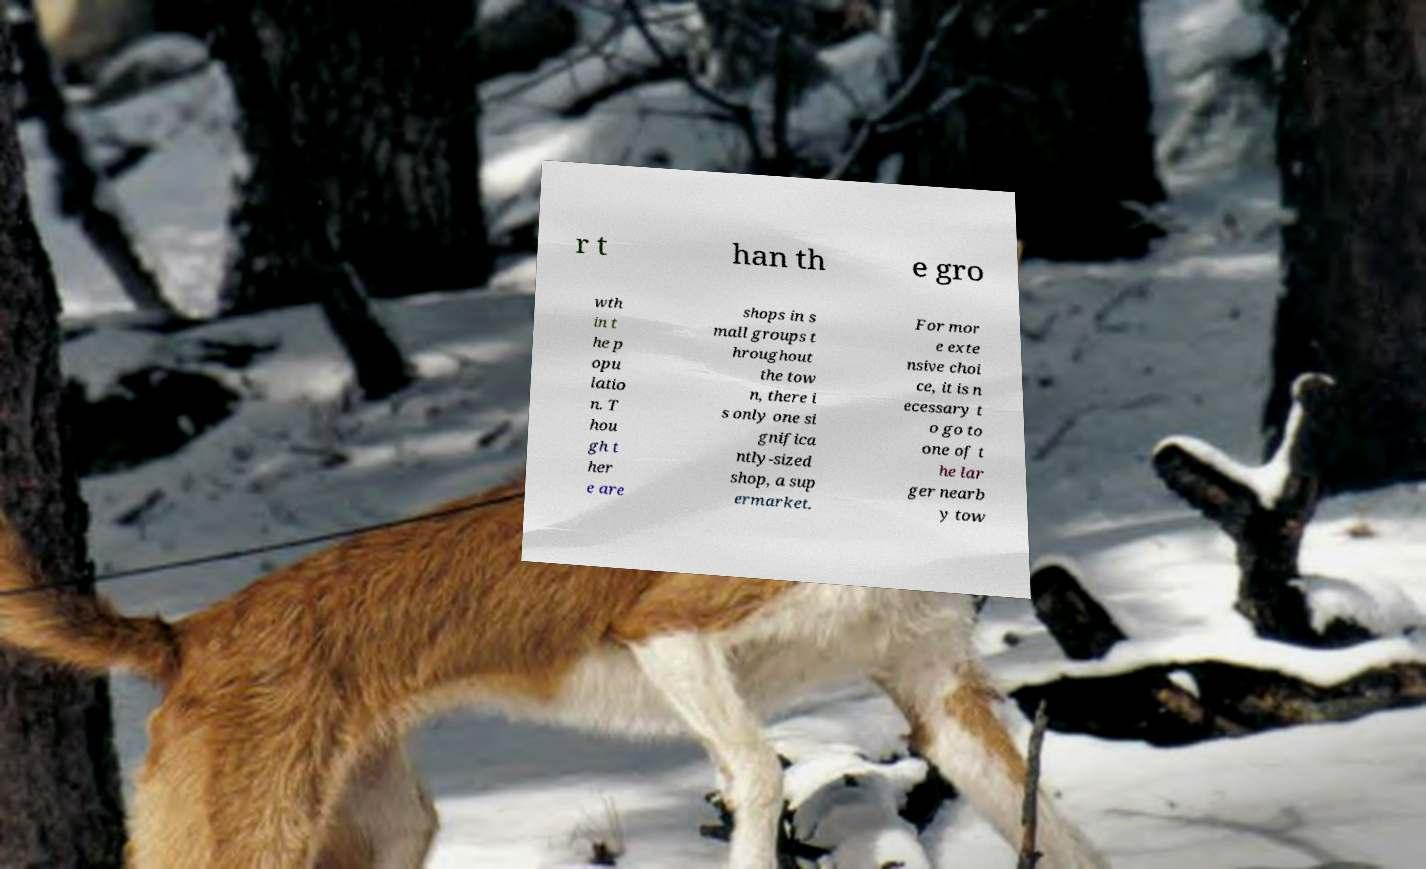Could you extract and type out the text from this image? r t han th e gro wth in t he p opu latio n. T hou gh t her e are shops in s mall groups t hroughout the tow n, there i s only one si gnifica ntly-sized shop, a sup ermarket. For mor e exte nsive choi ce, it is n ecessary t o go to one of t he lar ger nearb y tow 